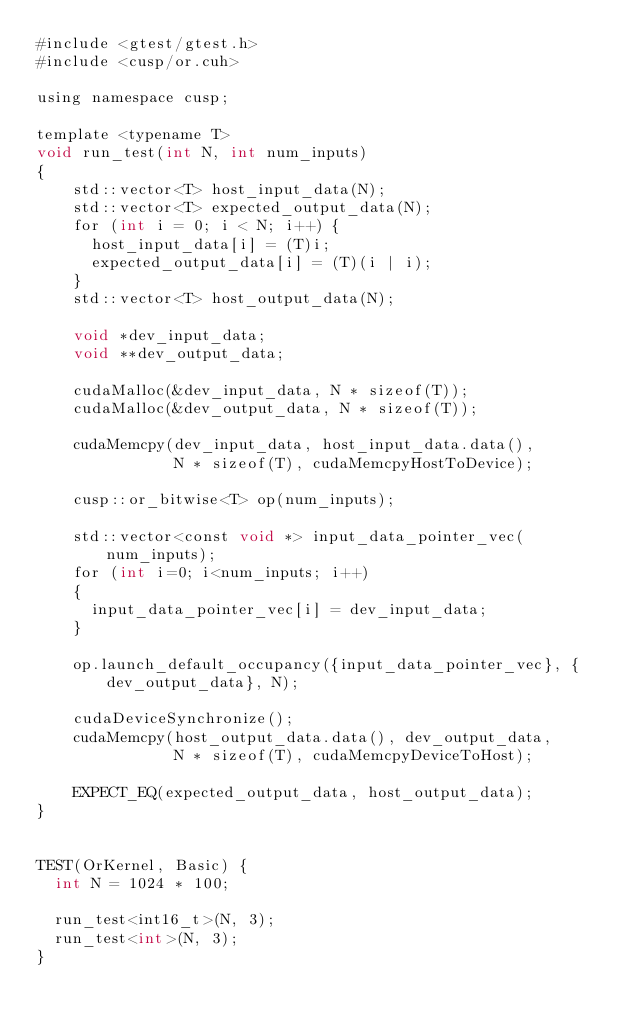Convert code to text. <code><loc_0><loc_0><loc_500><loc_500><_Cuda_>#include <gtest/gtest.h>
#include <cusp/or.cuh>

using namespace cusp;

template <typename T> 
void run_test(int N, int num_inputs)
{
    std::vector<T> host_input_data(N);
    std::vector<T> expected_output_data(N);
    for (int i = 0; i < N; i++) {
      host_input_data[i] = (T)i;
      expected_output_data[i] = (T)(i | i);
    }
    std::vector<T> host_output_data(N);
  
    void *dev_input_data;
    void **dev_output_data;
  
    cudaMalloc(&dev_input_data, N * sizeof(T));
    cudaMalloc(&dev_output_data, N * sizeof(T));

    cudaMemcpy(dev_input_data, host_input_data.data(),
               N * sizeof(T), cudaMemcpyHostToDevice);
  
    cusp::or_bitwise<T> op(num_inputs);

    std::vector<const void *> input_data_pointer_vec(num_inputs);
    for (int i=0; i<num_inputs; i++)
    {
      input_data_pointer_vec[i] = dev_input_data;
    }

    op.launch_default_occupancy({input_data_pointer_vec}, {dev_output_data}, N);
  
    cudaDeviceSynchronize();
    cudaMemcpy(host_output_data.data(), dev_output_data,
               N * sizeof(T), cudaMemcpyDeviceToHost);
  
    EXPECT_EQ(expected_output_data, host_output_data);
}


TEST(OrKernel, Basic) {
  int N = 1024 * 100;

  run_test<int16_t>(N, 3);
  run_test<int>(N, 3);
}</code> 